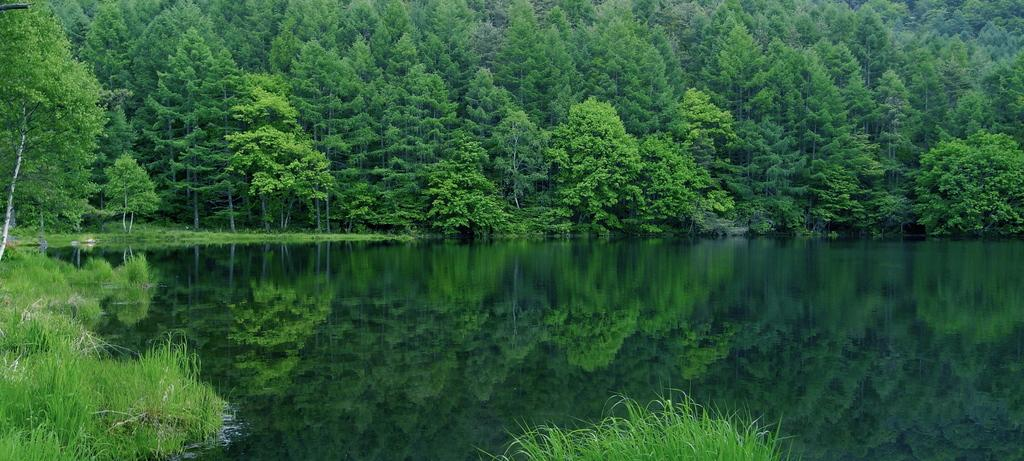What is visible in the image that is not solid? There is water visible in the image. What type of vegetation can be seen in the image? There are green color plants and trees in the image. What type of comb is used to style the trees in the image? There is no comb present in the image, and the trees are not styled. 